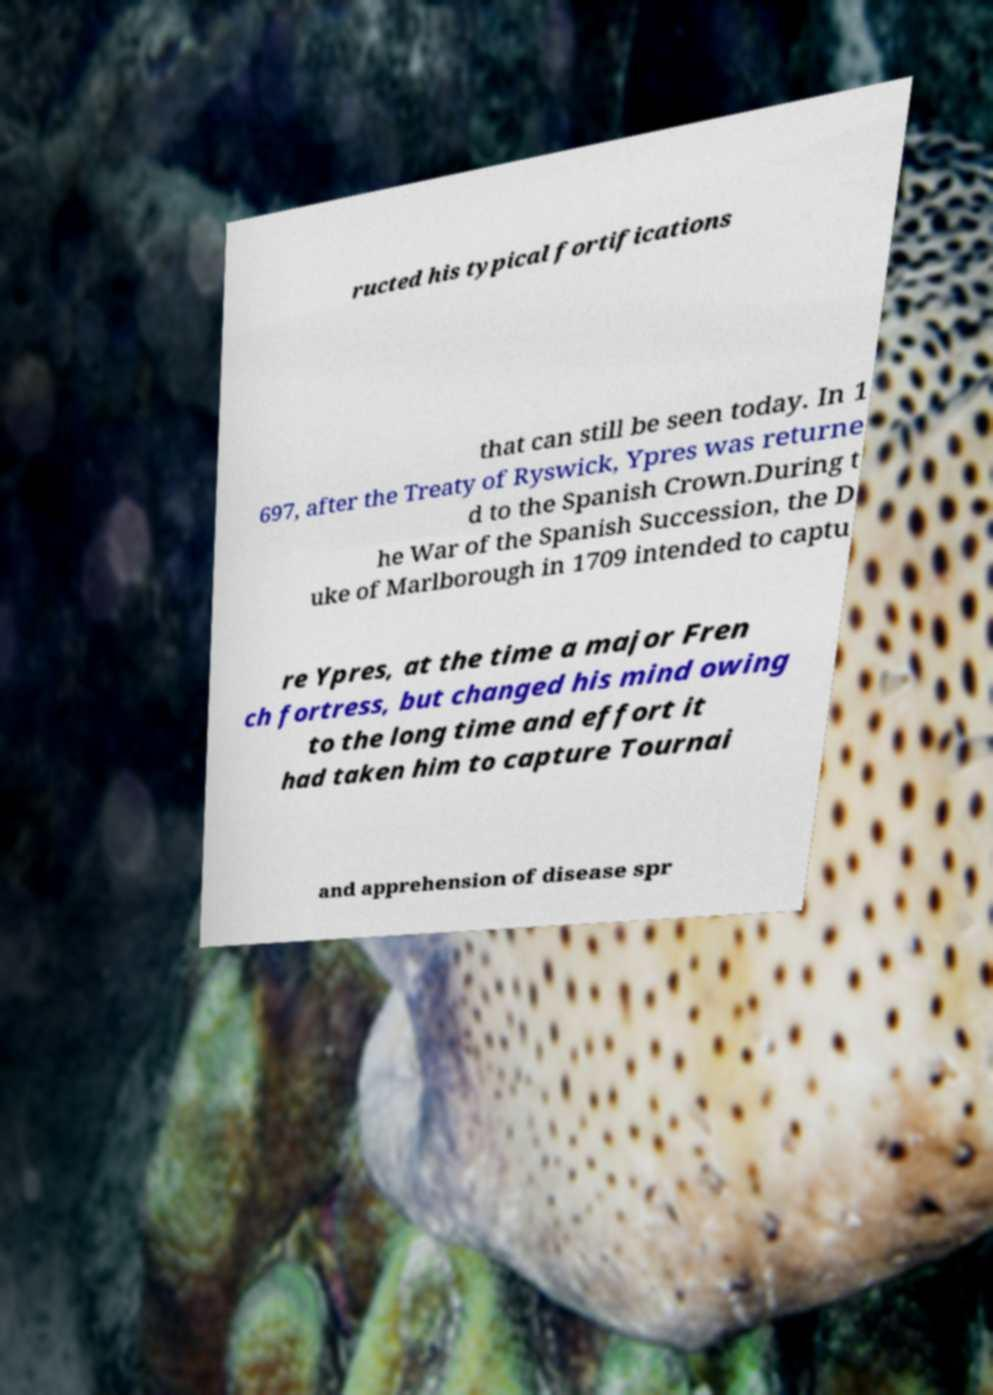Can you read and provide the text displayed in the image?This photo seems to have some interesting text. Can you extract and type it out for me? ructed his typical fortifications that can still be seen today. In 1 697, after the Treaty of Ryswick, Ypres was returne d to the Spanish Crown.During t he War of the Spanish Succession, the D uke of Marlborough in 1709 intended to captu re Ypres, at the time a major Fren ch fortress, but changed his mind owing to the long time and effort it had taken him to capture Tournai and apprehension of disease spr 